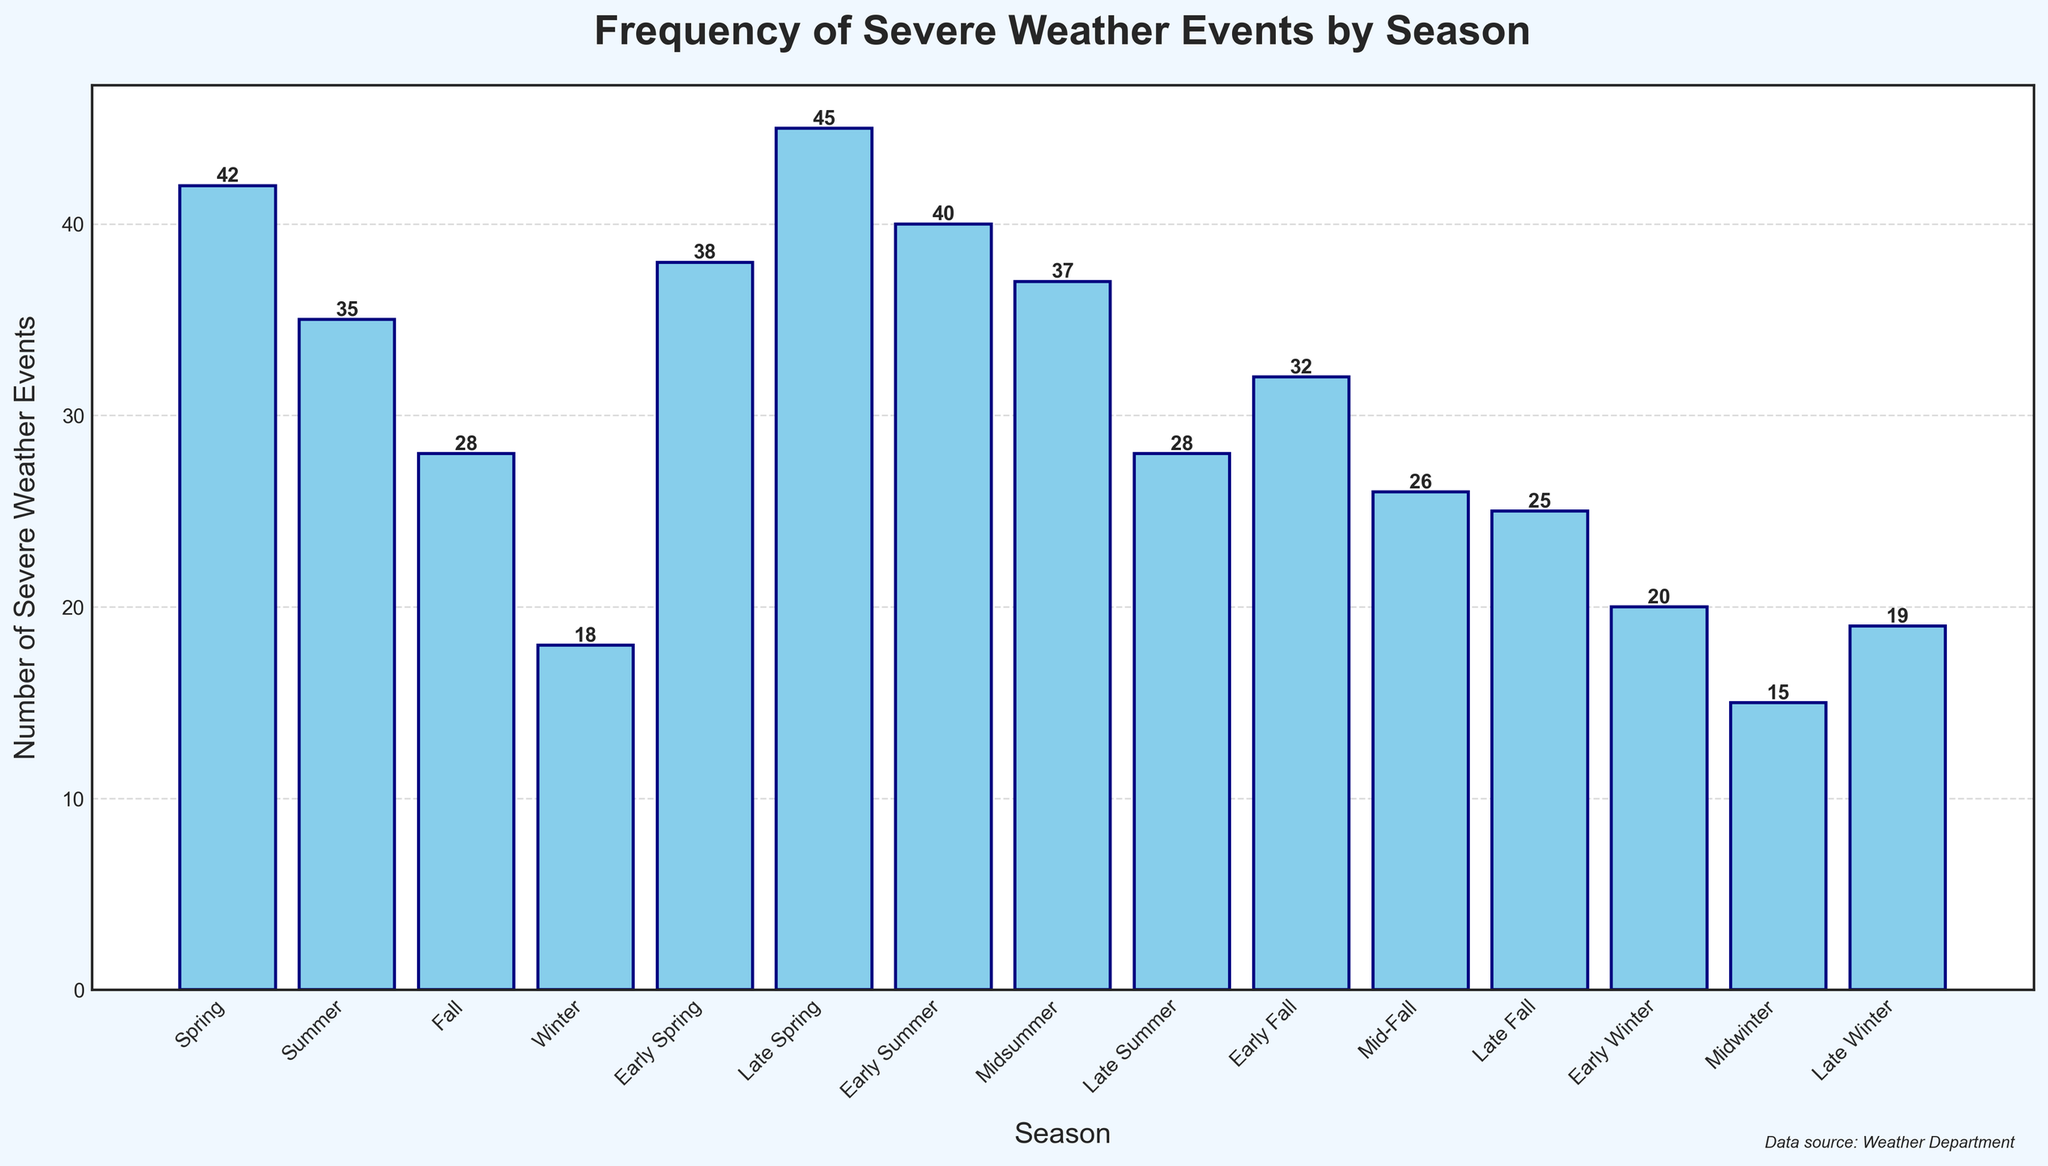Which season has the highest frequency of severe weather events? Examine the heights of the bars to determine which one is the tallest. The "Late Spring" bar is the tallest, indicating it has the highest frequency of events.
Answer: Late Spring What is the total number of severe weather events in all Spring subdivisions (Early Spring, Mid-Spring, Late Spring)? Add the values of severe weather events for Early Spring (38), Mid-Spring (42), and Late Spring (45). 38 + 42 + 45 equals 125.
Answer: 125 Which season has the lowest frequency of severe weather events? Examine the heights of the bars to determine which one is the shortest. The "Midwinter" bar is the shortest, indicating it has the lowest frequency of events.
Answer: Midwinter How many more severe weather events occurred in Early Summer compared to Early Winter? The bar for Early Summer (40) is compared to the bar for Early Winter (20). Subtract the two values: 40 - 20 equals 20.
Answer: 20 Which is higher, the number of severe weather events in Summer or Fall? Compare the total number of severe weather events in Summer (35) and Fall (28). Summer has a higher number.
Answer: Summer What is the average number of severe weather events during the Winter subdivisions (Early Winter, Midwinter, Late Winter)? Add the number of severe weather events for Early Winter (20), Midwinter (15), and Late Winter (19). Sum these values: 20 + 15 + 19 = 54. Then divide by the number of subdivisions (3). 54/3 equals 18.
Answer: 18 Which specific subdivision has the second highest frequency of severe weather events? First, identify the highest frequency, which is Late Spring (45). Then look for the next highest; Early Spring (38) is closer than the main seasons.
Answer: Early Spring 